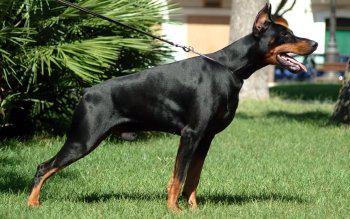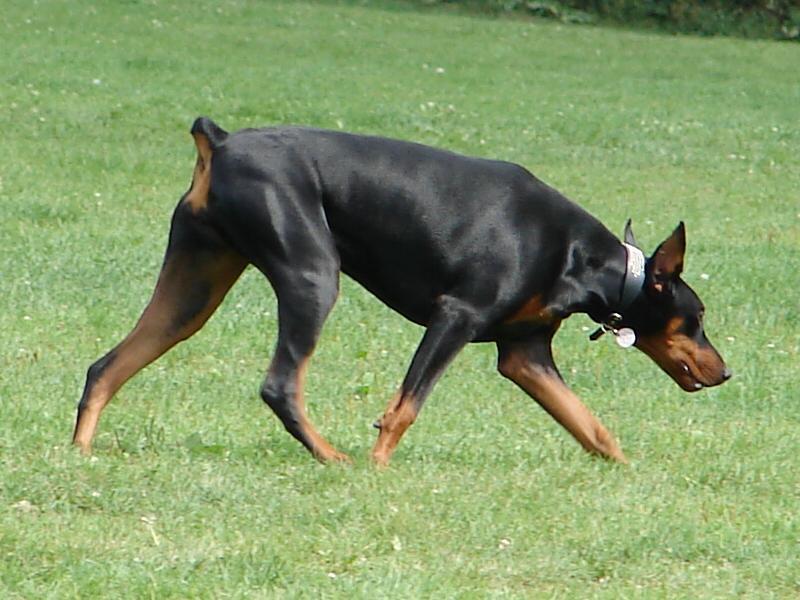The first image is the image on the left, the second image is the image on the right. Analyze the images presented: Is the assertion "A minimum of 3 dogs are present" valid? Answer yes or no. No. The first image is the image on the left, the second image is the image on the right. Analyze the images presented: Is the assertion "The right image contains exactly two dogs." valid? Answer yes or no. No. 